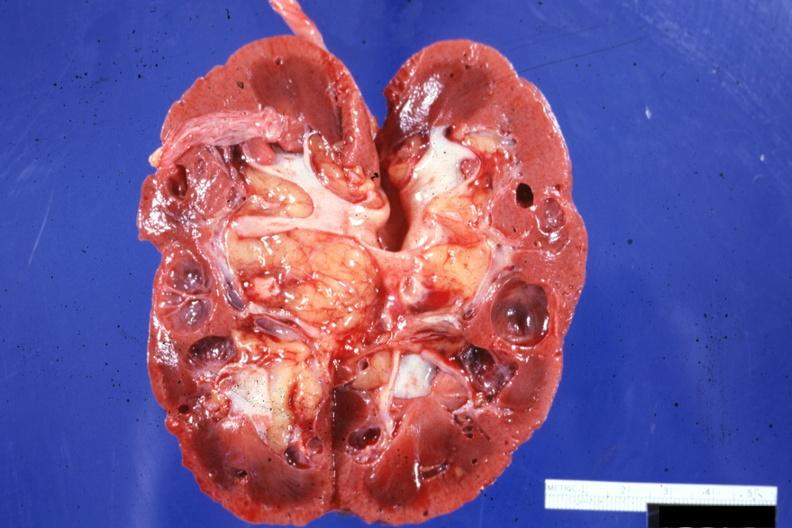s postoperative cardiac surgery present?
Answer the question using a single word or phrase. No 